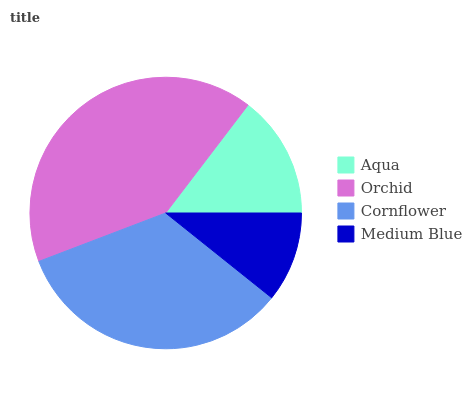Is Medium Blue the minimum?
Answer yes or no. Yes. Is Orchid the maximum?
Answer yes or no. Yes. Is Cornflower the minimum?
Answer yes or no. No. Is Cornflower the maximum?
Answer yes or no. No. Is Orchid greater than Cornflower?
Answer yes or no. Yes. Is Cornflower less than Orchid?
Answer yes or no. Yes. Is Cornflower greater than Orchid?
Answer yes or no. No. Is Orchid less than Cornflower?
Answer yes or no. No. Is Cornflower the high median?
Answer yes or no. Yes. Is Aqua the low median?
Answer yes or no. Yes. Is Medium Blue the high median?
Answer yes or no. No. Is Cornflower the low median?
Answer yes or no. No. 